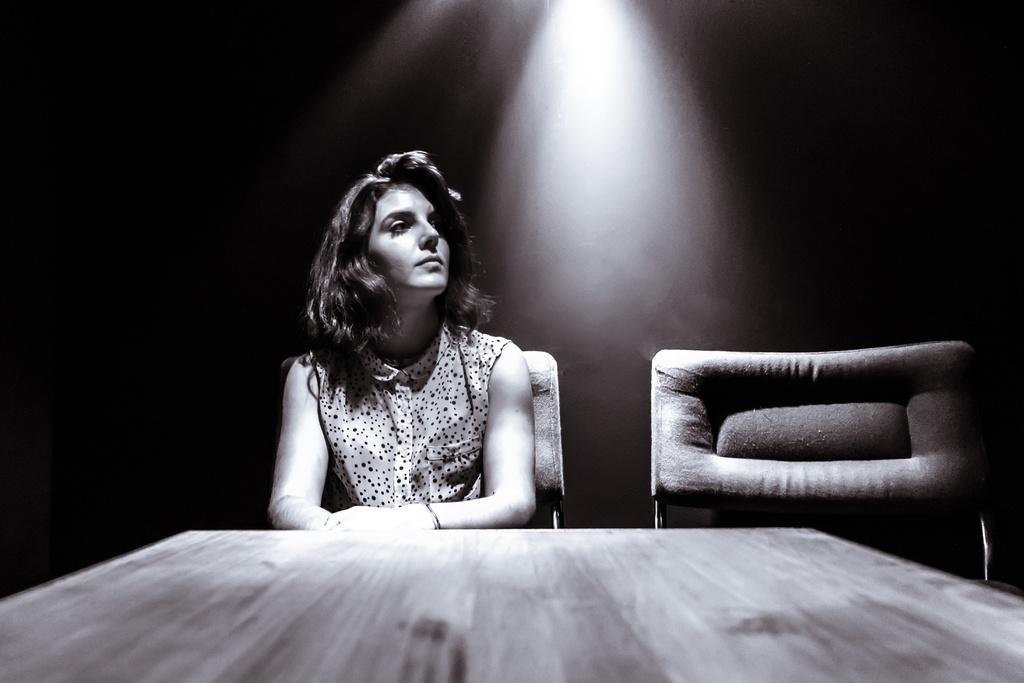Could you give a brief overview of what you see in this image? In this image there is a table truncated towards the bottom of the image, there are chairs, there is a person sitting on the chair, there is a light, the background of the image is dark. 